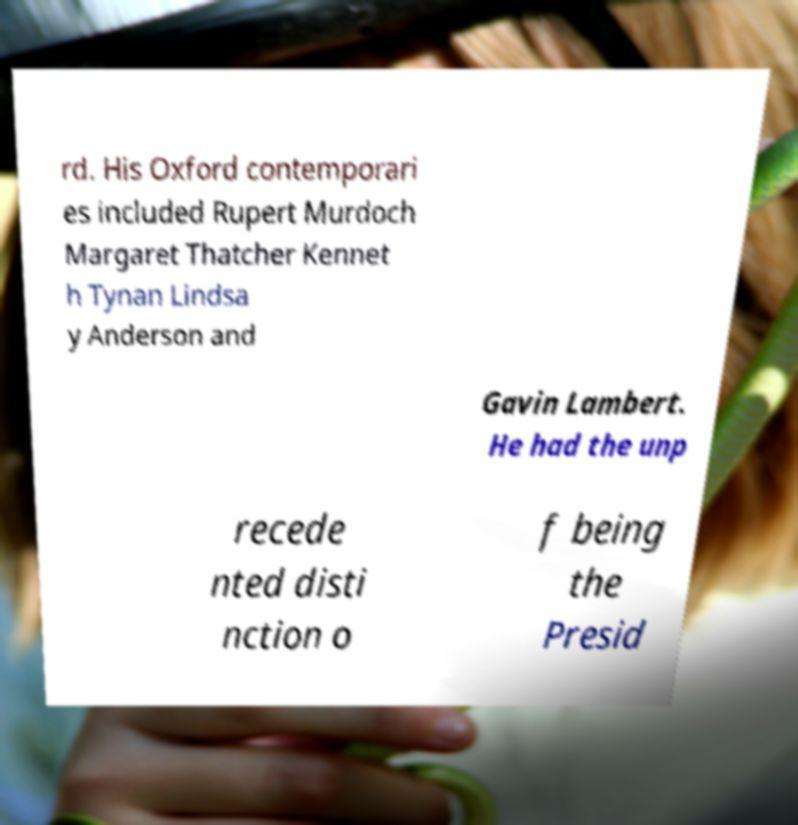Can you read and provide the text displayed in the image?This photo seems to have some interesting text. Can you extract and type it out for me? rd. His Oxford contemporari es included Rupert Murdoch Margaret Thatcher Kennet h Tynan Lindsa y Anderson and Gavin Lambert. He had the unp recede nted disti nction o f being the Presid 